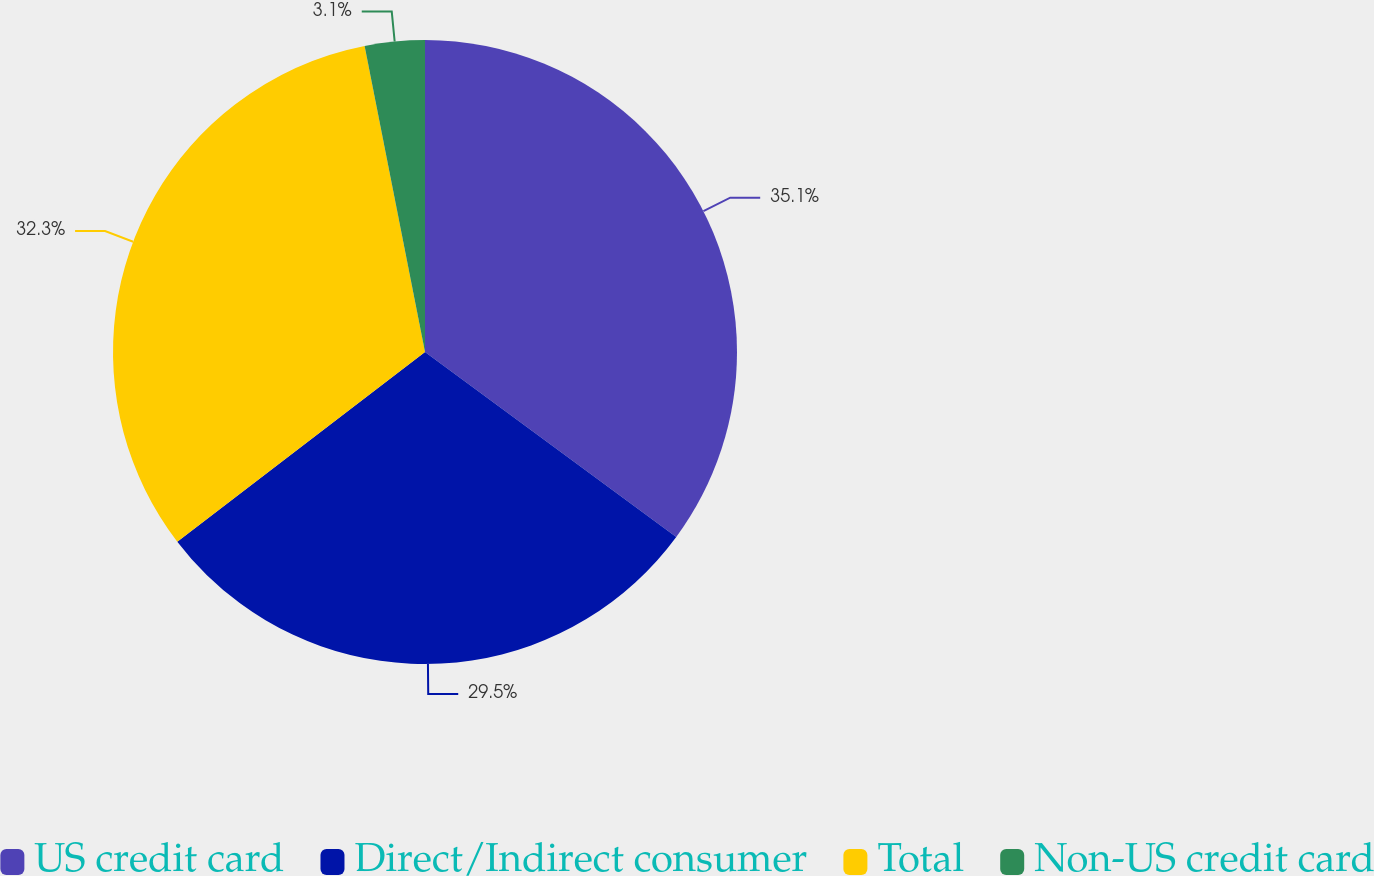Convert chart to OTSL. <chart><loc_0><loc_0><loc_500><loc_500><pie_chart><fcel>US credit card<fcel>Direct/Indirect consumer<fcel>Total<fcel>Non-US credit card<nl><fcel>35.1%<fcel>29.5%<fcel>32.3%<fcel>3.1%<nl></chart> 